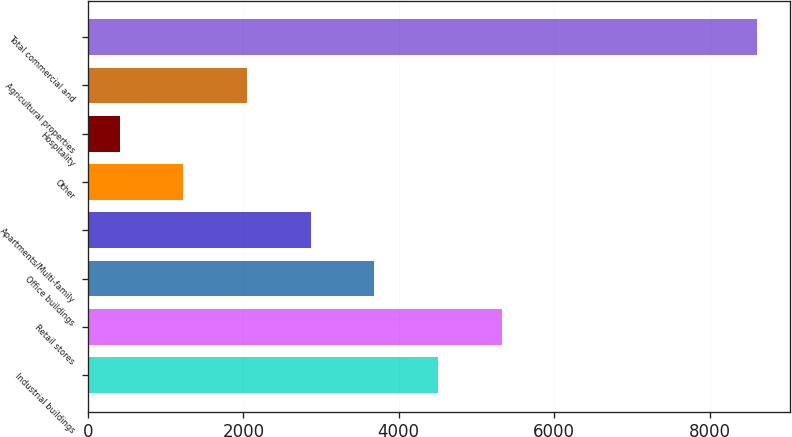<chart> <loc_0><loc_0><loc_500><loc_500><bar_chart><fcel>Industrial buildings<fcel>Retail stores<fcel>Office buildings<fcel>Apartments/Multi-family<fcel>Other<fcel>Hospitality<fcel>Agricultural properties<fcel>Total commercial and<nl><fcel>4507.5<fcel>5327.6<fcel>3687.4<fcel>2867.3<fcel>1227.1<fcel>407<fcel>2047.2<fcel>8608<nl></chart> 